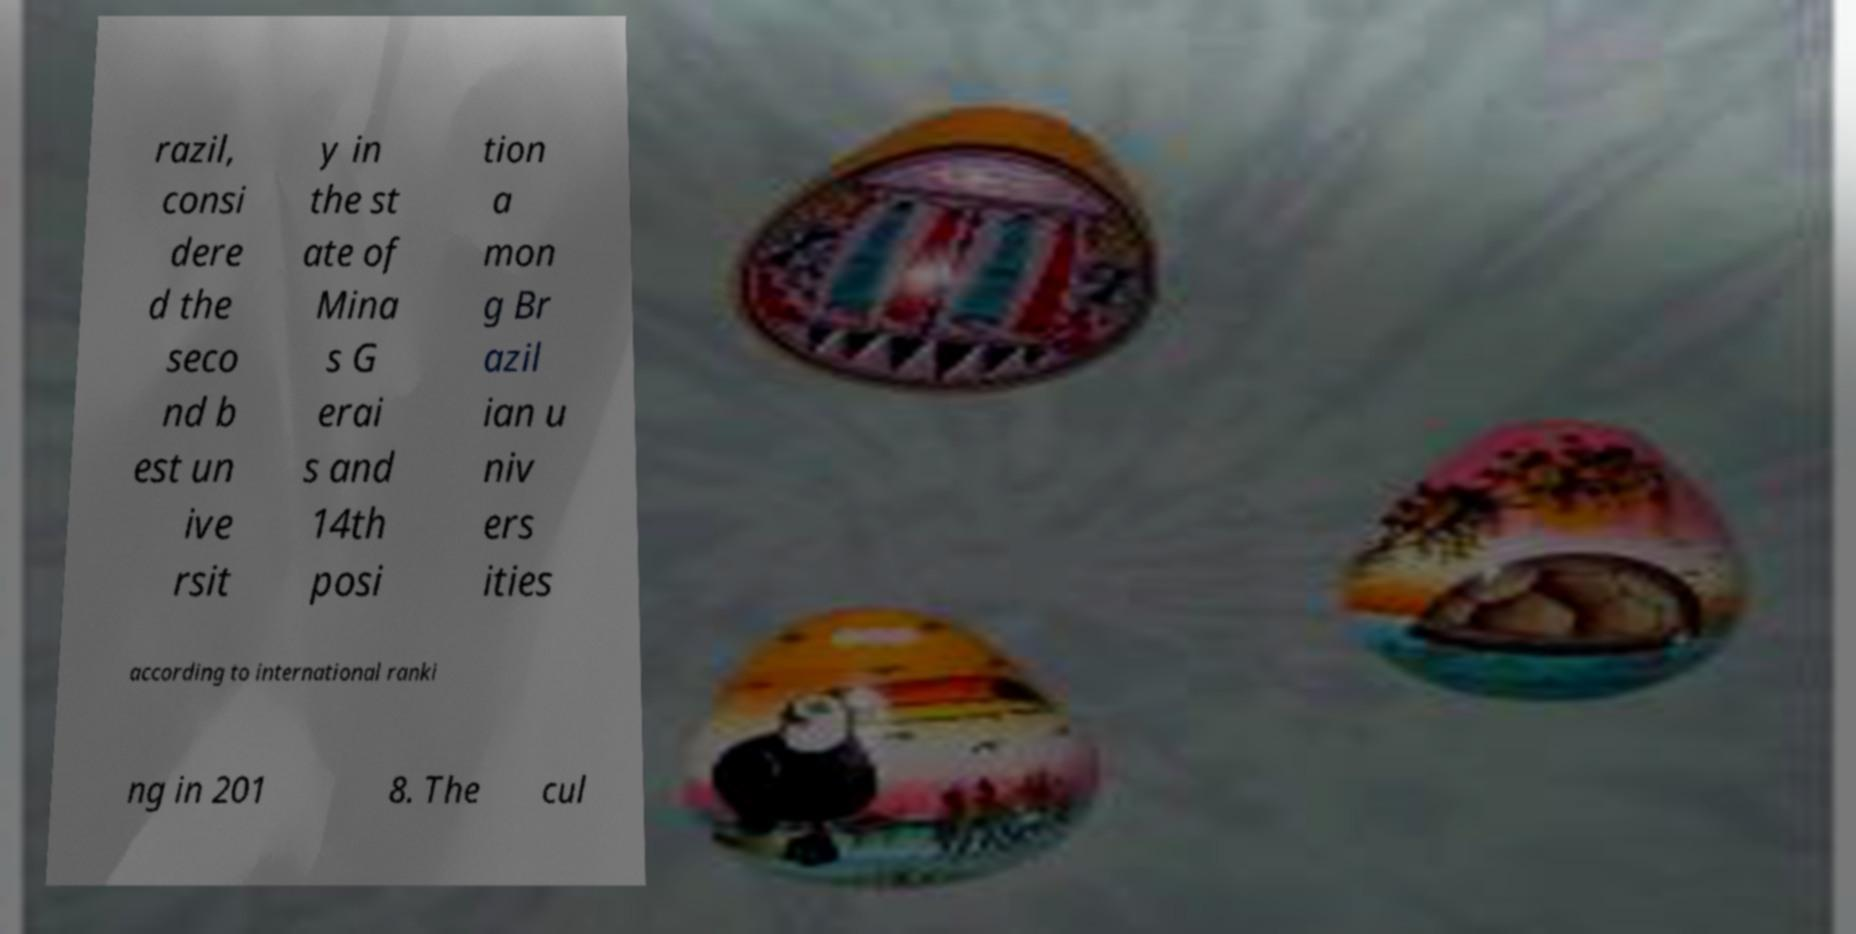Can you read and provide the text displayed in the image?This photo seems to have some interesting text. Can you extract and type it out for me? razil, consi dere d the seco nd b est un ive rsit y in the st ate of Mina s G erai s and 14th posi tion a mon g Br azil ian u niv ers ities according to international ranki ng in 201 8. The cul 